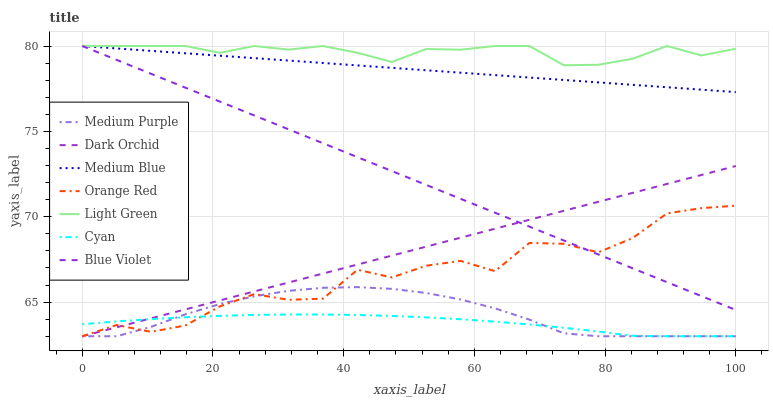Does Cyan have the minimum area under the curve?
Answer yes or no. Yes. Does Light Green have the maximum area under the curve?
Answer yes or no. Yes. Does Dark Orchid have the minimum area under the curve?
Answer yes or no. No. Does Dark Orchid have the maximum area under the curve?
Answer yes or no. No. Is Dark Orchid the smoothest?
Answer yes or no. Yes. Is Orange Red the roughest?
Answer yes or no. Yes. Is Medium Purple the smoothest?
Answer yes or no. No. Is Medium Purple the roughest?
Answer yes or no. No. Does Dark Orchid have the lowest value?
Answer yes or no. Yes. Does Light Green have the lowest value?
Answer yes or no. No. Does Blue Violet have the highest value?
Answer yes or no. Yes. Does Dark Orchid have the highest value?
Answer yes or no. No. Is Cyan less than Blue Violet?
Answer yes or no. Yes. Is Medium Blue greater than Orange Red?
Answer yes or no. Yes. Does Medium Blue intersect Blue Violet?
Answer yes or no. Yes. Is Medium Blue less than Blue Violet?
Answer yes or no. No. Is Medium Blue greater than Blue Violet?
Answer yes or no. No. Does Cyan intersect Blue Violet?
Answer yes or no. No. 